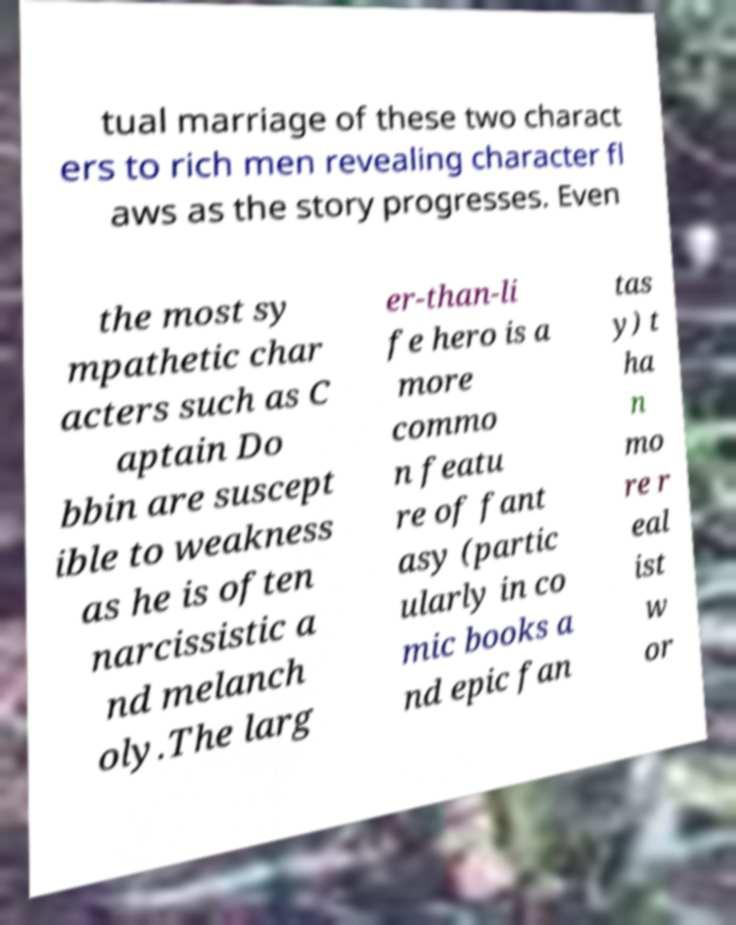Can you accurately transcribe the text from the provided image for me? tual marriage of these two charact ers to rich men revealing character fl aws as the story progresses. Even the most sy mpathetic char acters such as C aptain Do bbin are suscept ible to weakness as he is often narcissistic a nd melanch oly.The larg er-than-li fe hero is a more commo n featu re of fant asy (partic ularly in co mic books a nd epic fan tas y) t ha n mo re r eal ist w or 